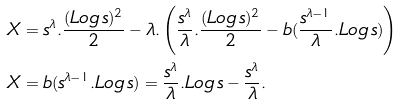Convert formula to latex. <formula><loc_0><loc_0><loc_500><loc_500>& X = s ^ { \lambda } . \frac { ( L o g \, s ) ^ { 2 } } { 2 } - \lambda . \left ( \frac { s ^ { \lambda } } { \lambda } . \frac { ( L o g \, s ) ^ { 2 } } { 2 } - b ( \frac { s ^ { \lambda - 1 } } { \lambda } . L o g \, s ) \right ) \\ & X = b ( s ^ { \lambda - 1 } . L o g \, s ) = \frac { s ^ { \lambda } } { \lambda } . L o g \, s - \frac { s ^ { \lambda } } { \lambda } .</formula> 